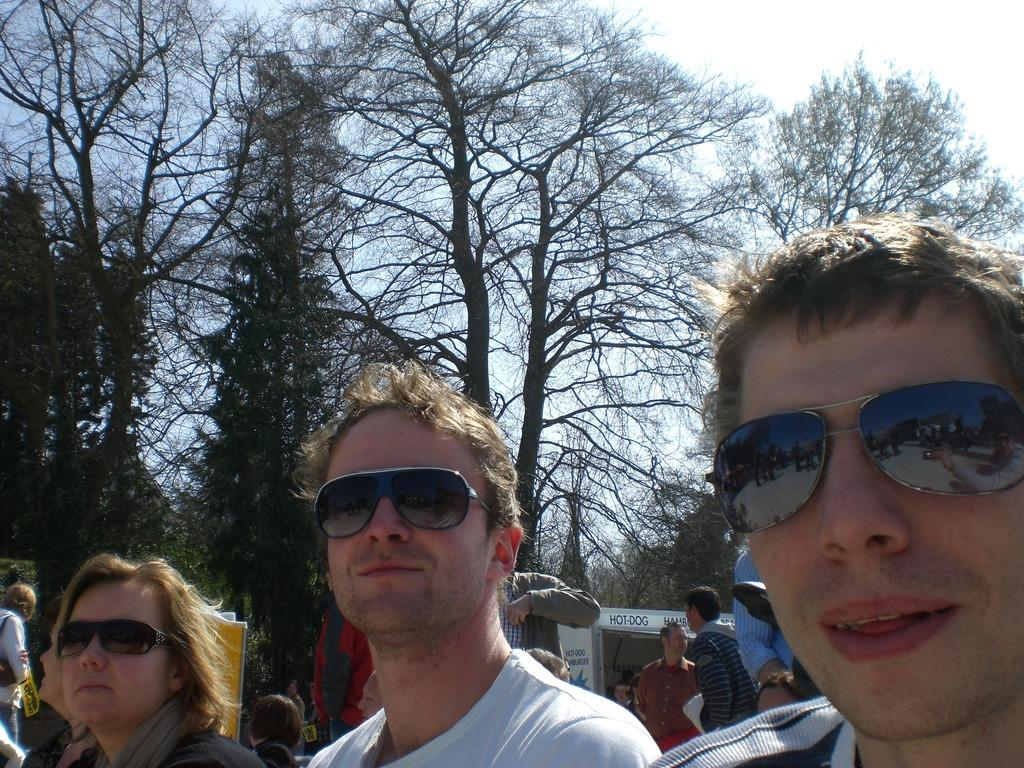<image>
Describe the image concisely. People are sitting in front of a hamburger and hotdog stand. 